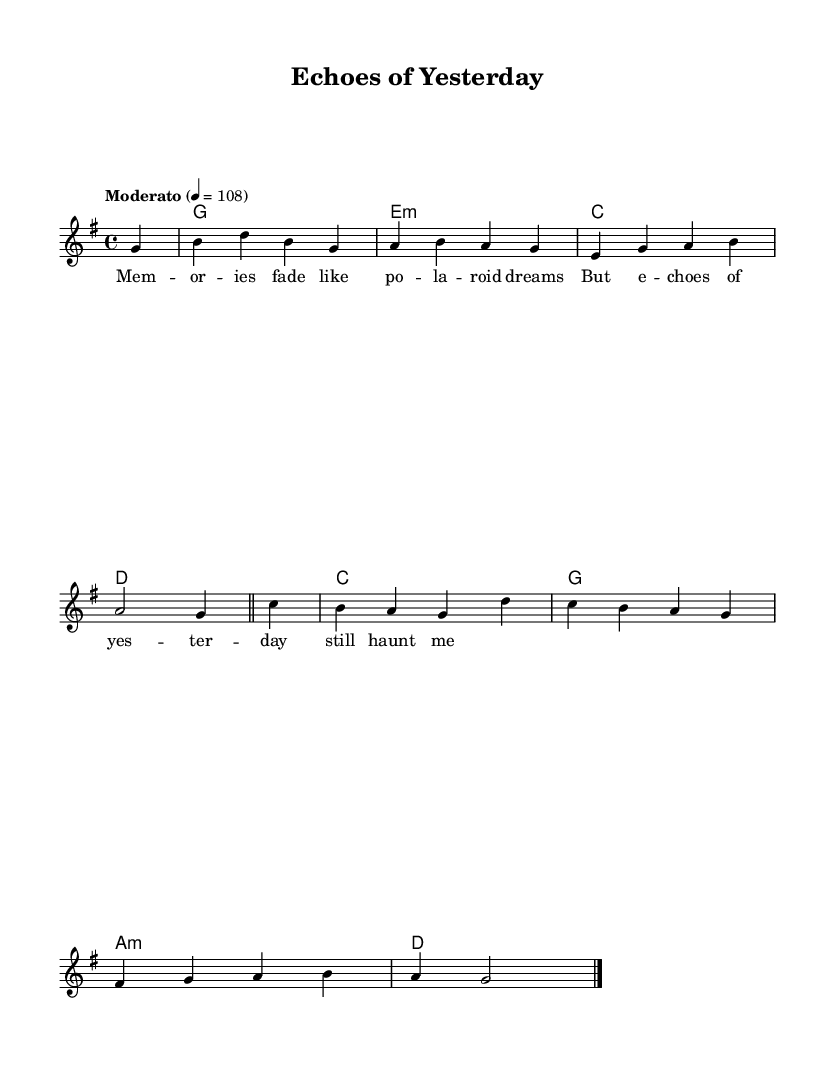What is the key signature of this music? The key signature is G major as indicated by the one sharp (F#) in the key signature at the beginning of the score.
Answer: G major What is the time signature of the piece? The time signature is 4/4, which means there are four beats per measure and each quarter note gets one beat. This can be found at the start of the piece.
Answer: 4/4 What is the tempo marking for the music? The tempo marking is "Moderato" with a metronome marking of 4 = 108, indicating a moderately paced piece. This is specified at the beginning of the score.
Answer: Moderato, 4 = 108 How many measures are in the melody? The melody contains a total of 8 measures, counted by the vertical bar lines that separate each measure.
Answer: 8 What is the predominant chord used in the first measure? The predominant chord used in the first measure is G major, which is what the chord name indicates at the start of the score.
Answer: G What is the lyrical theme suggested by the lyrics? The lyrics suggest a theme of nostalgia and memory, as they speak about fading memories and echoes from the past. This can be interpreted from the phrases used in the lyrics.
Answer: Nostalgia How does the structure of the song reflect typical indie pop elements? The structure combines introspective lyrics with a simple melody and harmony, typical of indie pop, which often emphasizes emotional depth and acoustic elements, evident in the acoustic-electric fusion described.
Answer: Introspection and fusion 